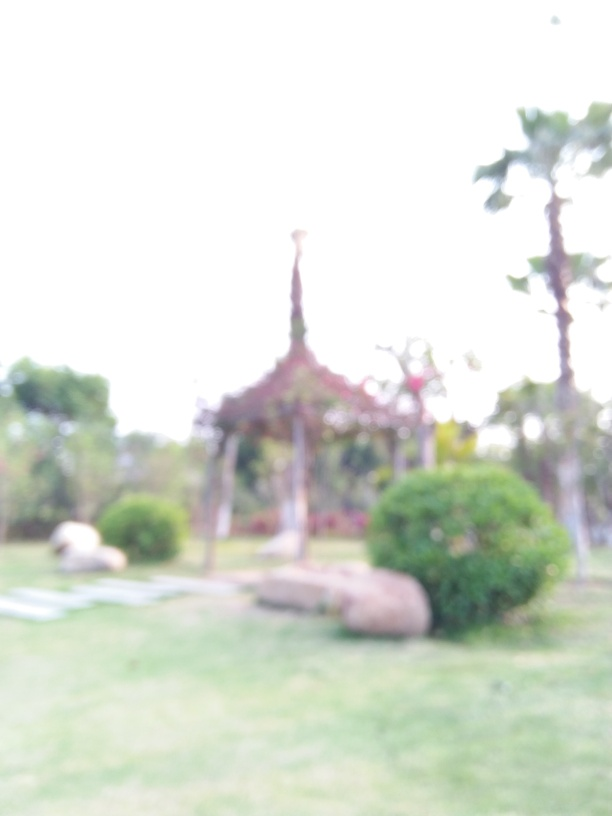What is the quality of this image?
A. Extremely poor
B. Outstanding
C. Excellent The quality of the image is below average due to its blurred appearance, affecting the viewer's ability to discern details and appreciate the scene. While it's clear that the photo captures an outdoor setting, potentially a park with trees and perhaps a structure, the lack of sharpness and detail suggests that the image's quality is far from excellent or outstanding. Without finer details, it's hard to fully evaluate the content or the photographic technique used. It usually indicates that the focus wasn't set correctly or that the camera was moving while the shot was taken. 